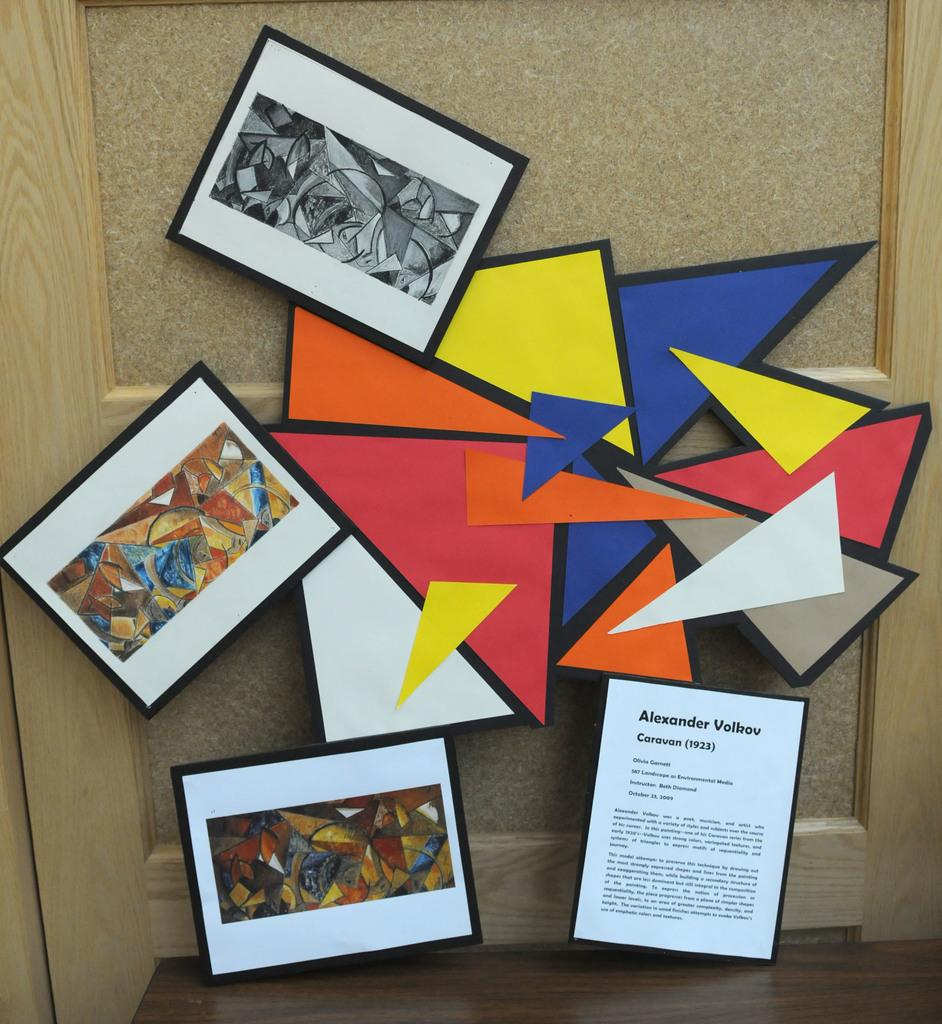<image>
Summarize the visual content of the image. An art display about the artist Alexander Volkov. 